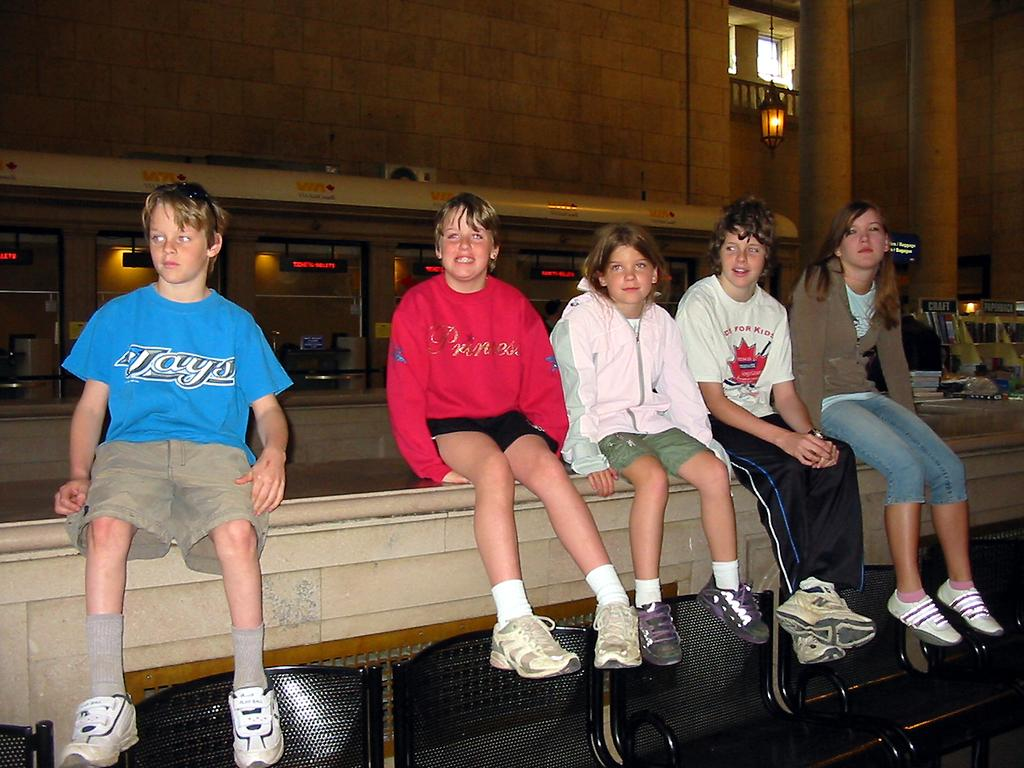What are the children doing in the image? The children are sitting on a wall in the image. Are there any objects near the wall? Yes, there are chairs near the wall. What can be seen in the background of the image? There is a building in the background. What is providing illumination in the image? There are lights visible in the image. What type of signage is present in the image? There are name boards present. Where is the faucet located in the image? There is no faucet present in the image. What type of pancake is being served to the children in the image? There is no pancake present in the image. 